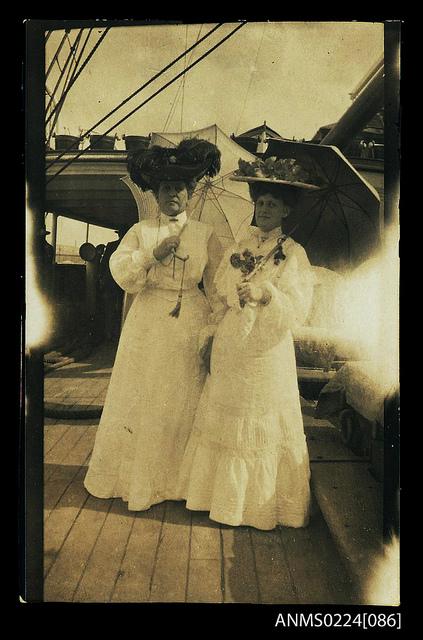How many people are wearing hats in this photo?
Keep it brief. 2. Are the woman wearing short dresses?
Answer briefly. No. What does the caption in the lower right side of the photo say?
Keep it brief. Anm5022(086). Is the photo colored?
Keep it brief. No. 